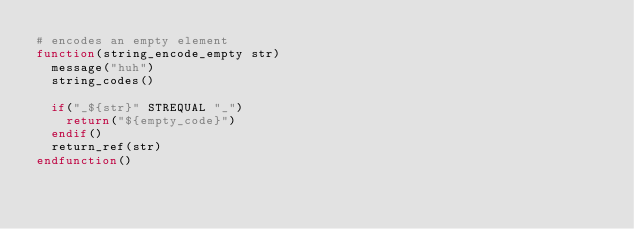<code> <loc_0><loc_0><loc_500><loc_500><_CMake_># encodes an empty element
function(string_encode_empty str)
  message("huh")
  string_codes()

  if("_${str}" STREQUAL "_")
    return("${empty_code}")
  endif()
  return_ref(str)
endfunction()




</code> 